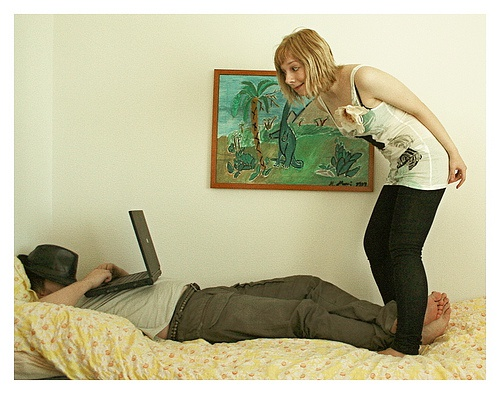Describe the objects in this image and their specific colors. I can see bed in white, khaki, and tan tones, people in white, black, khaki, tan, and beige tones, people in white, darkgreen, black, and tan tones, and laptop in white, darkgreen, black, and gray tones in this image. 